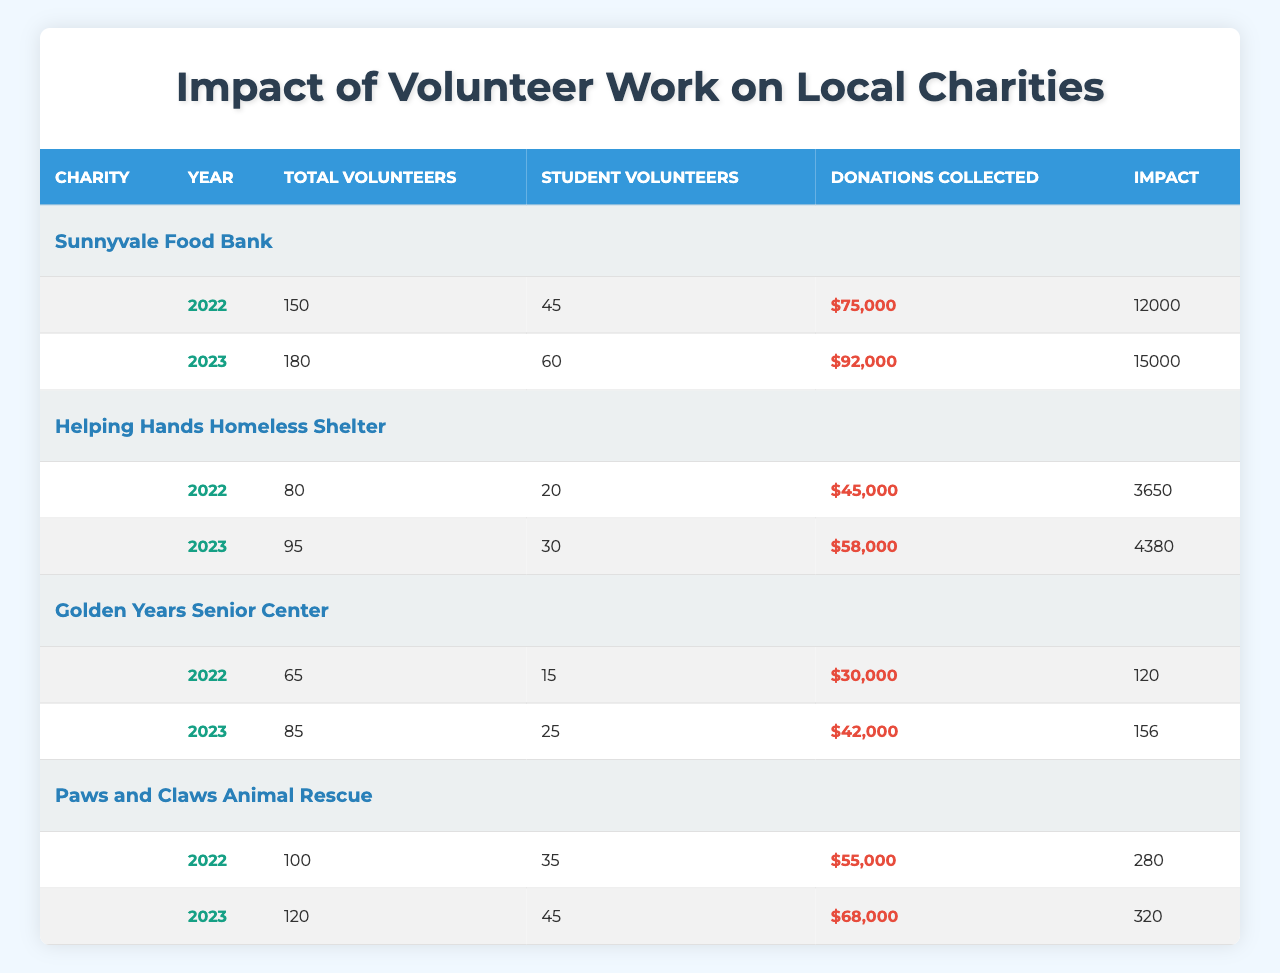What is the total number of volunteers for the Sunnyvale Food Bank in 2023? In the table, I found that the total number of volunteers for the Sunnyvale Food Bank in 2023 is listed directly under that column for that year. According to the data, it is 180.
Answer: 180 How many meals were served by the Sunnyvale Food Bank in 2023? The table specifically states that the number of meals served by the Sunnyvale Food Bank in 2023 is 15,000, as indicated in the corresponding impact column.
Answer: 15,000 What was the total amount of donations collected by Golden Years Senior Center in 2022? The table shows the donations collected for Golden Years Senior Center in 2022, which is listed as $30,000 in the donations column for that year.
Answer: $30,000 Did the Helping Hands Homeless Shelter receive more donations in 2023 than in 2022? Looking at the donations column for Helping Hands Homeless Shelter, I see that they collected $58,000 in 2023 and $45,000 in 2022. Since 58,000 is greater than 45,000, the statement is true.
Answer: Yes What is the difference in the number of student volunteers for Paws and Claws Animal Rescue between 2022 and 2023? The table shows that Paws and Claws had 35 student volunteers in 2022 and 45 in 2023. To find the difference, I subtract 35 from 45, which gives me 10.
Answer: 10 Which charity served the most meals in 2023? Referring to the table, I can see that the Sunnyvale Food Bank served 15,000 meals in 2023, whereas the other charities are focused on different services. Therefore, it is the charity with the highest number of meals served.
Answer: Sunnyvale Food Bank What is the total number of nights of shelter provided by Helping Hands Homeless Shelter in 2023? The table shows that the nights of shelter provided by Helping Hands Homeless Shelter in 2023 is directly stated as 4,380 in the corresponding impact column for that year.
Answer: 4,380 What was the increase in donations collected by the Golden Years Senior Center from 2022 to 2023? For Golden Years Senior Center, donations were $30,000 in 2022 and $42,000 in 2023. The increase is calculated by subtracting the 2022 donations from the 2023 donations: $42,000 - $30,000 = $12,000.
Answer: $12,000 How many total meals were served by Sunnyvale Food Bank over the years 2022 and 2023? The table shows 12,000 meals served in 2022 and 15,000 meals served in 2023 for the Sunnyvale Food Bank. Adding these together, 12,000 + 15,000 gives a total of 27,000 meals served.
Answer: 27,000 What is the average number of student volunteers across all charities in 2023? I will first find the number of student volunteers for each charity in 2023. They are: 60 (Sunnyvale), 30 (Helping Hands), 25 (Golden Years), and 45 (Paws and Claws). The sum of these is 60 + 30 + 25 + 45 = 160. There are four charities, so I divide the total by 4: 160 / 4 = 40.
Answer: 40 